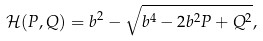Convert formula to latex. <formula><loc_0><loc_0><loc_500><loc_500>\mathcal { H } ( P , Q ) = b ^ { 2 } - \sqrt { b ^ { 4 } - 2 b ^ { 2 } P + Q ^ { 2 } } ,</formula> 